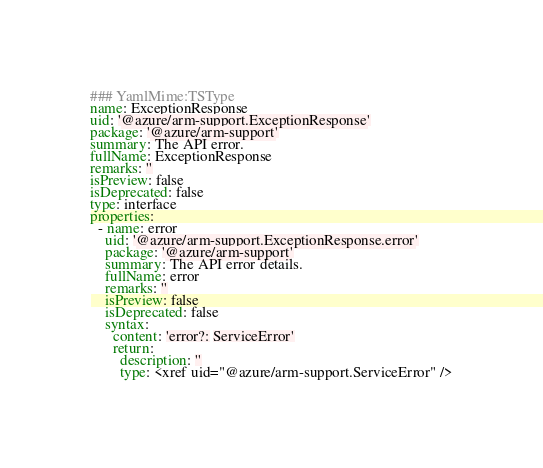Convert code to text. <code><loc_0><loc_0><loc_500><loc_500><_YAML_>### YamlMime:TSType
name: ExceptionResponse
uid: '@azure/arm-support.ExceptionResponse'
package: '@azure/arm-support'
summary: The API error.
fullName: ExceptionResponse
remarks: ''
isPreview: false
isDeprecated: false
type: interface
properties:
  - name: error
    uid: '@azure/arm-support.ExceptionResponse.error'
    package: '@azure/arm-support'
    summary: The API error details.
    fullName: error
    remarks: ''
    isPreview: false
    isDeprecated: false
    syntax:
      content: 'error?: ServiceError'
      return:
        description: ''
        type: <xref uid="@azure/arm-support.ServiceError" />
</code> 